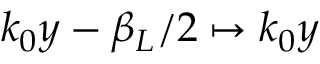Convert formula to latex. <formula><loc_0><loc_0><loc_500><loc_500>k _ { 0 } y - \beta _ { L } / 2 \mapsto k _ { 0 } y</formula> 